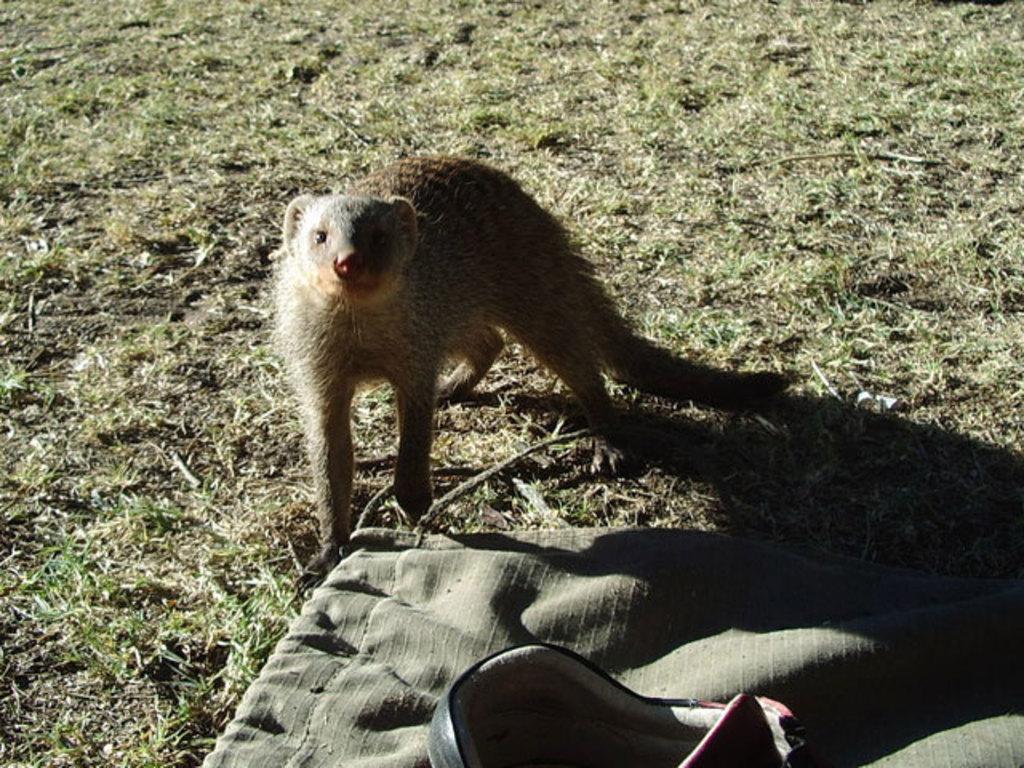Please provide a concise description of this image. In this picture there is a ferret animal who is standing on the ground. At the bottom I can see the cloth and baby trolley. 